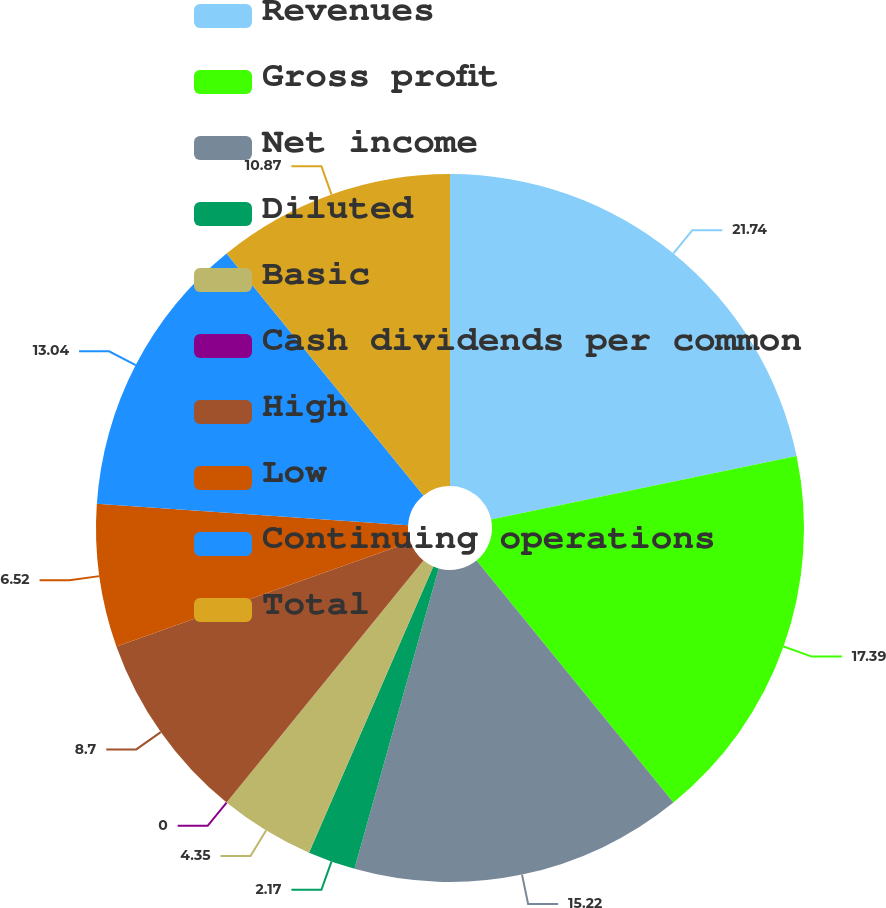<chart> <loc_0><loc_0><loc_500><loc_500><pie_chart><fcel>Revenues<fcel>Gross profit<fcel>Net income<fcel>Diluted<fcel>Basic<fcel>Cash dividends per common<fcel>High<fcel>Low<fcel>Continuing operations<fcel>Total<nl><fcel>21.74%<fcel>17.39%<fcel>15.22%<fcel>2.17%<fcel>4.35%<fcel>0.0%<fcel>8.7%<fcel>6.52%<fcel>13.04%<fcel>10.87%<nl></chart> 